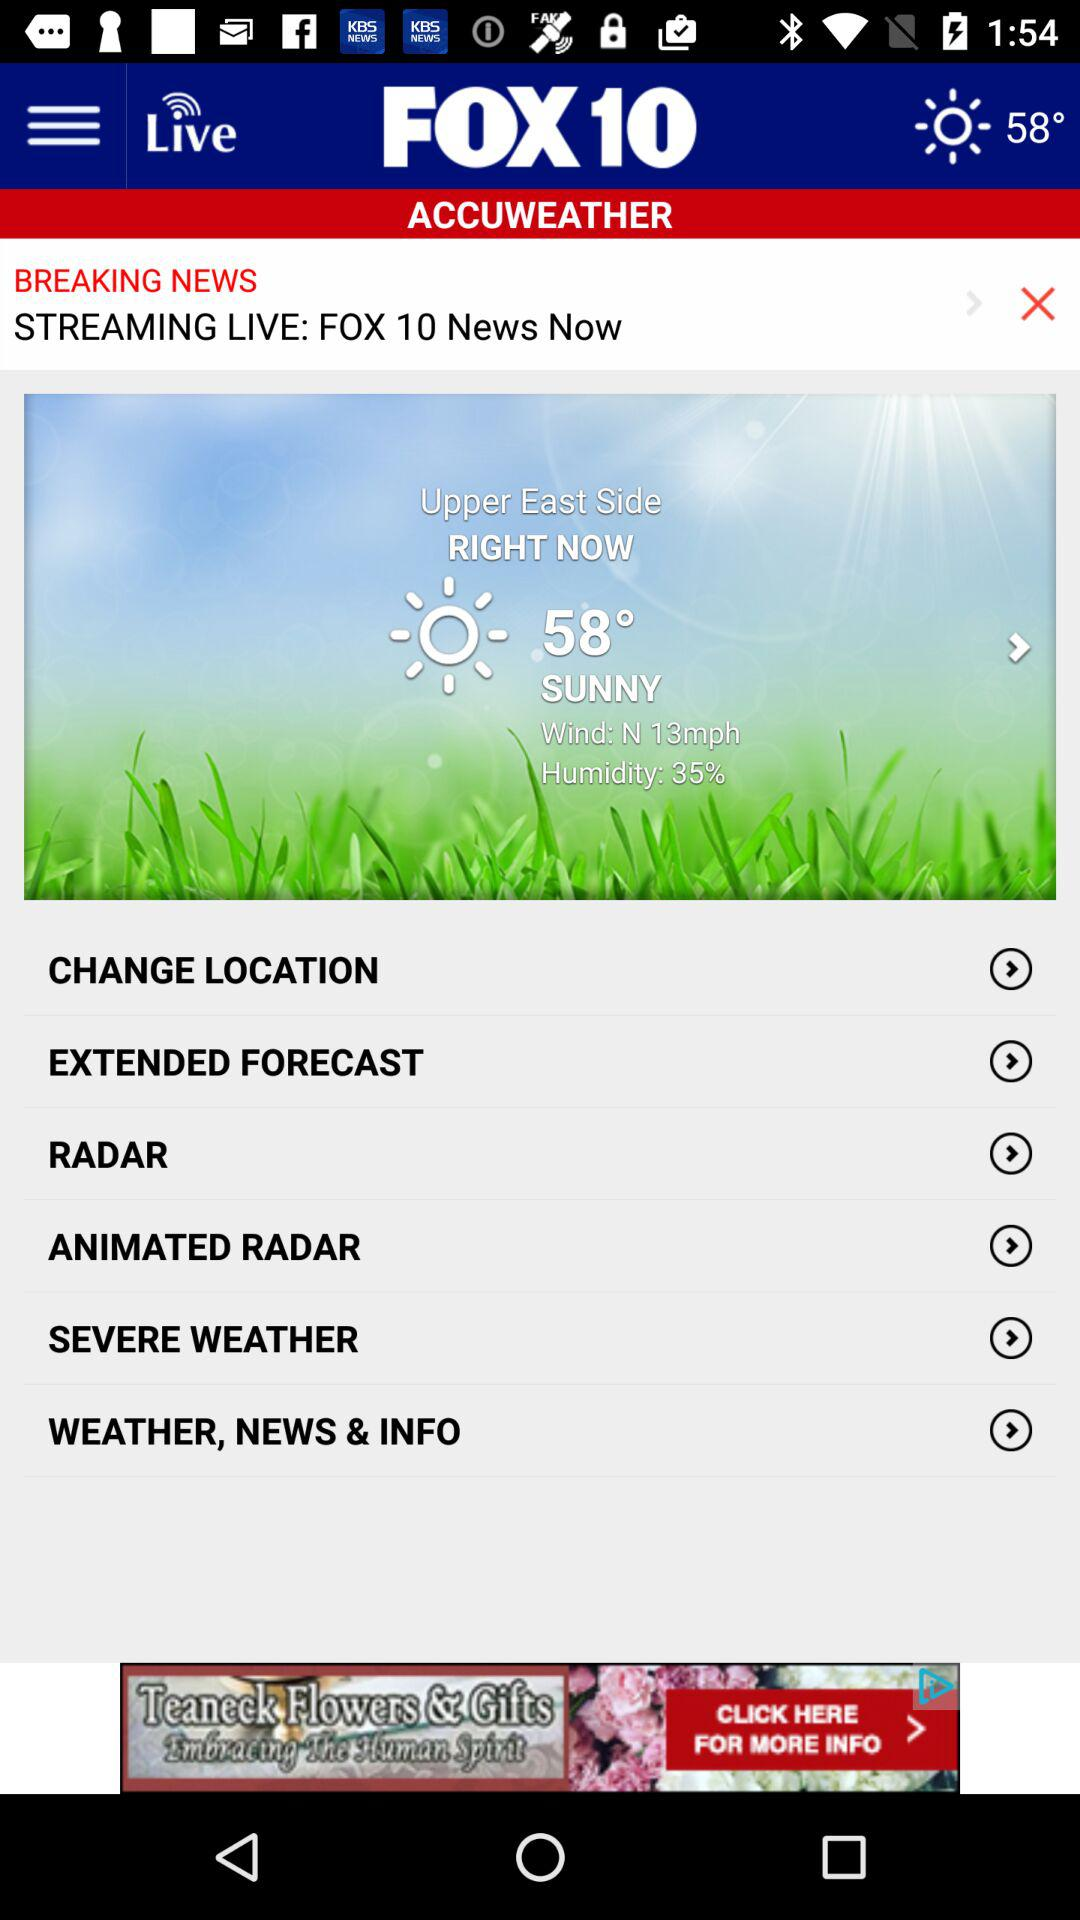What news channel is streaming live? The channel that is streaming live is "FOX 10 News". 